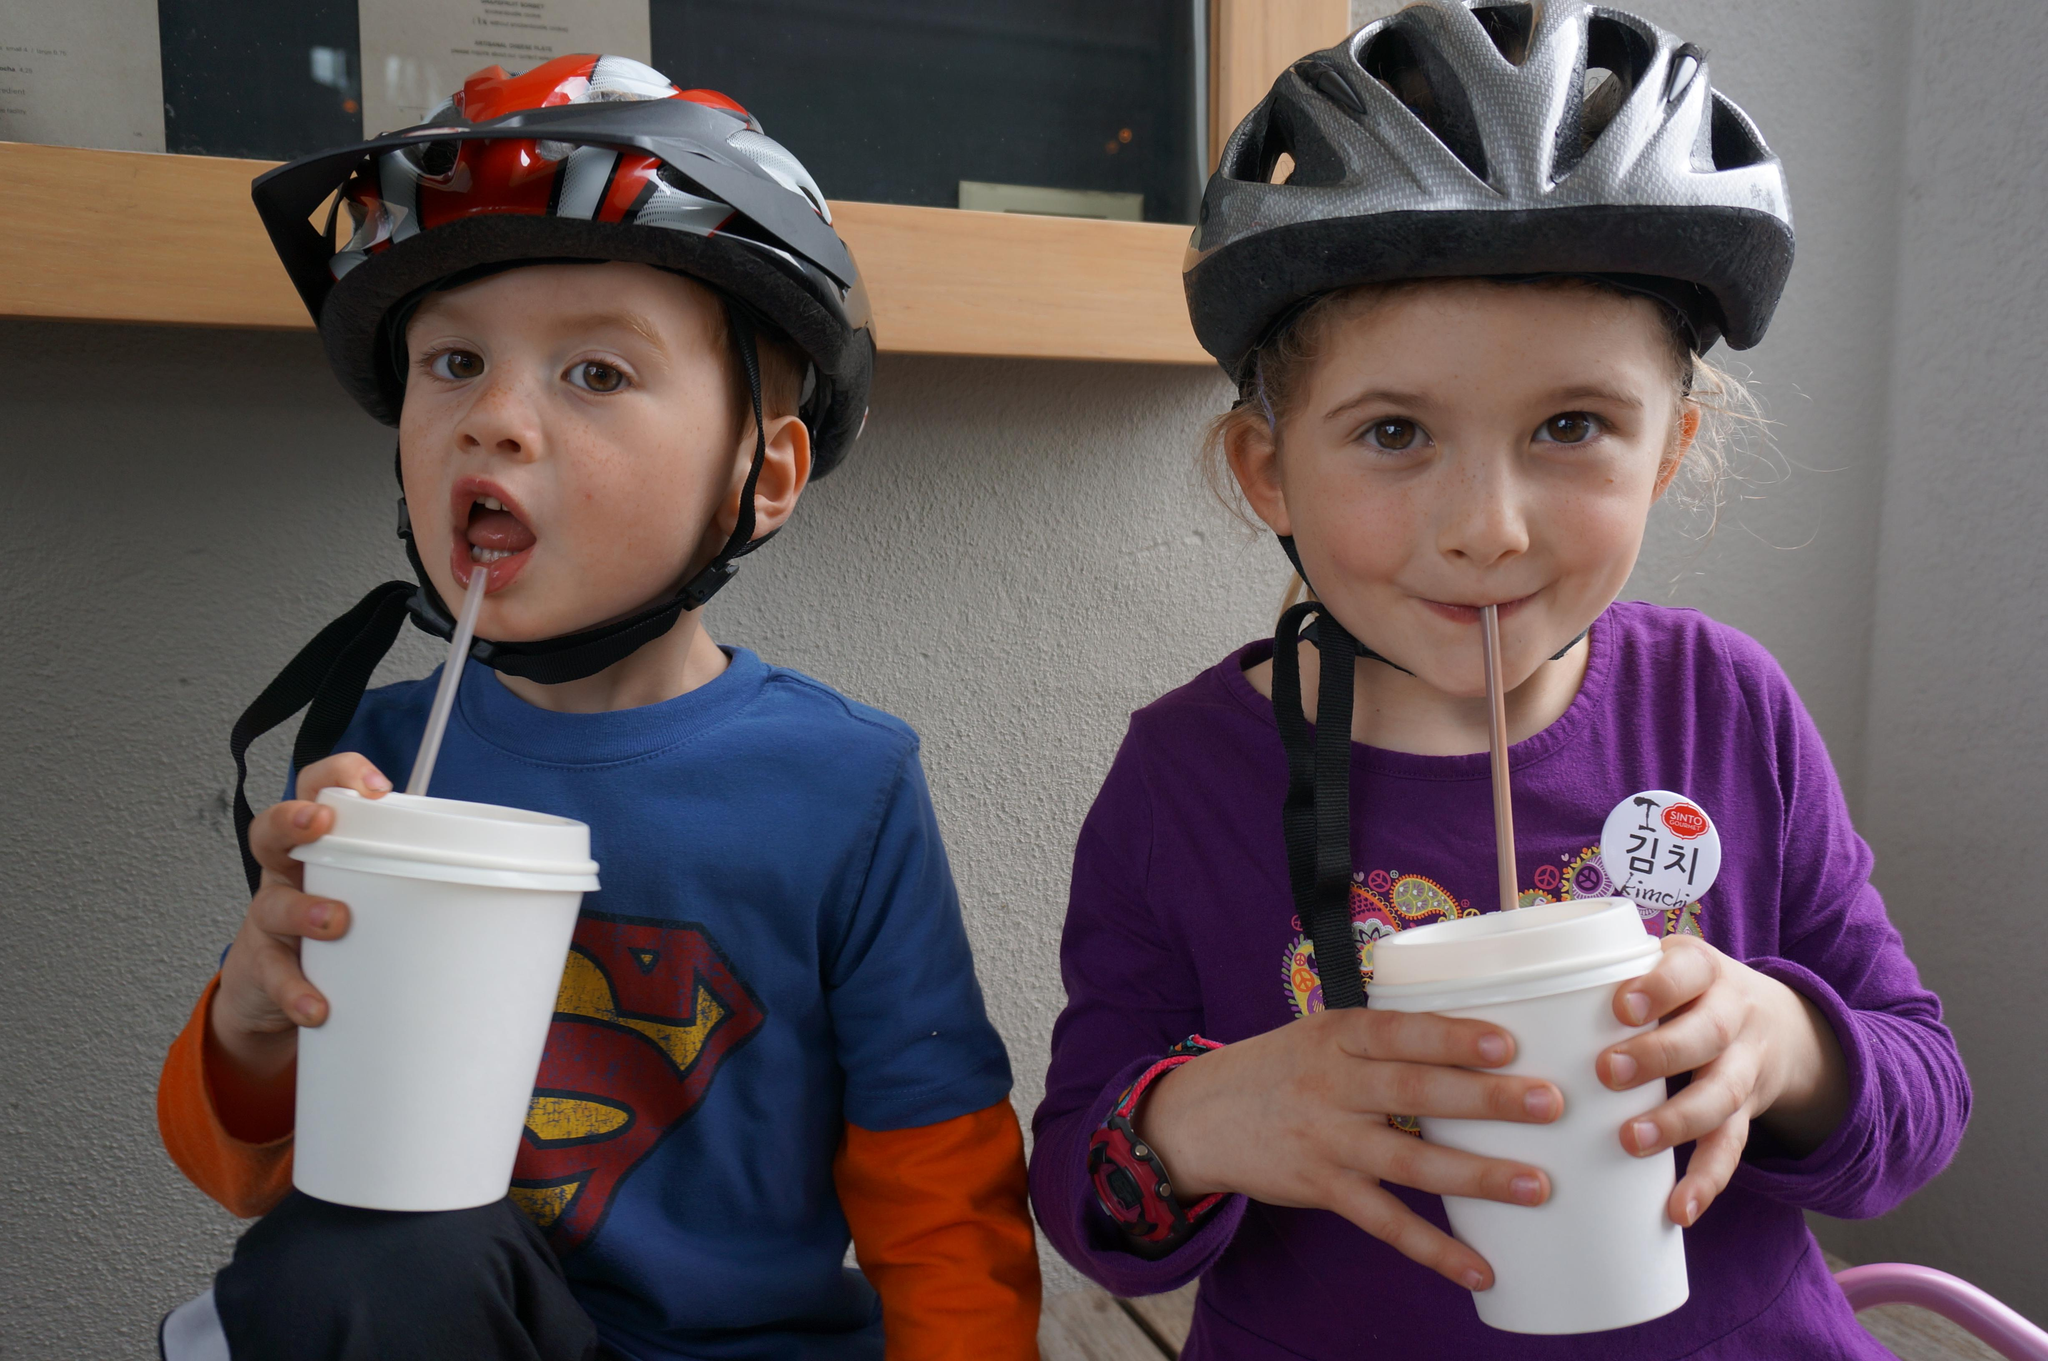How many kids are in the image? There are two kids in the image. What are the kids doing in the image? The kids are sitting and holding cups. What expressions do the kids have in the image? The kids are smiling in the image. What can be seen in the background of the image? There is a wall in the background of the image. Is there any decoration on the wall? Yes, there is a frame on the wall. What type of zephyr can be seen flying around the kids in the image? There is no zephyr present in the image; it is a term used to describe a gentle breeze, which cannot be seen. How many geese are visible in the image? There are no geese present in the image. 